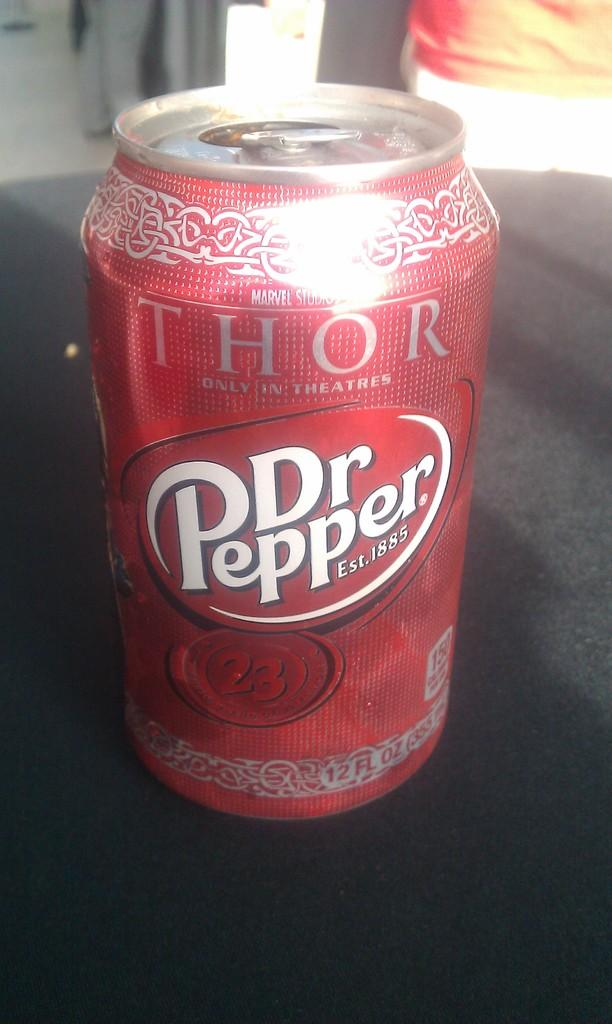<image>
Give a short and clear explanation of the subsequent image. Dr. Pepper is advertising the movie Thor on their 12 oz cans. 